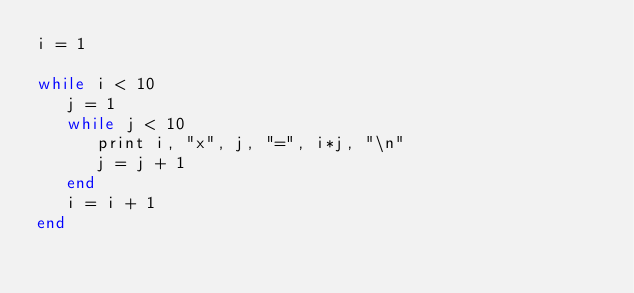<code> <loc_0><loc_0><loc_500><loc_500><_Ruby_>i = 1

while i < 10
   j = 1
   while j < 10
      print i, "x", j, "=", i*j, "\n"
      j = j + 1
   end
   i = i + 1
end</code> 